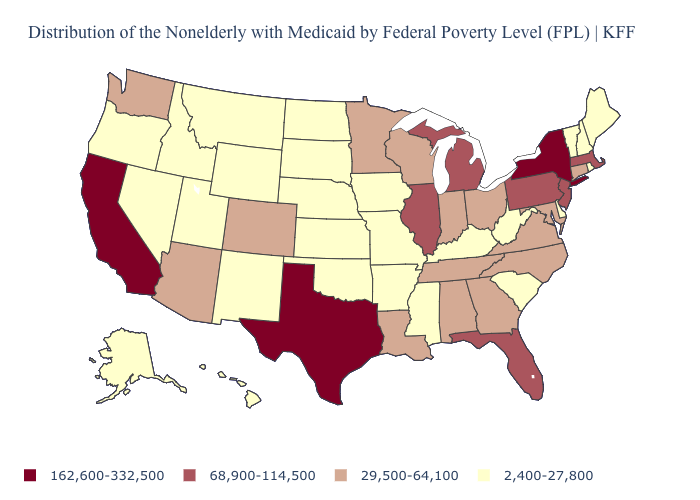Among the states that border Vermont , does New Hampshire have the highest value?
Concise answer only. No. What is the value of South Carolina?
Write a very short answer. 2,400-27,800. Which states hav the highest value in the West?
Concise answer only. California. What is the highest value in states that border Maryland?
Concise answer only. 68,900-114,500. Name the states that have a value in the range 162,600-332,500?
Give a very brief answer. California, New York, Texas. Among the states that border Indiana , which have the lowest value?
Quick response, please. Kentucky. Does Nevada have the same value as West Virginia?
Quick response, please. Yes. Name the states that have a value in the range 29,500-64,100?
Answer briefly. Alabama, Arizona, Colorado, Connecticut, Georgia, Indiana, Louisiana, Maryland, Minnesota, North Carolina, Ohio, Tennessee, Virginia, Washington, Wisconsin. What is the value of New Jersey?
Keep it brief. 68,900-114,500. Which states have the highest value in the USA?
Short answer required. California, New York, Texas. What is the value of West Virginia?
Write a very short answer. 2,400-27,800. What is the value of West Virginia?
Short answer required. 2,400-27,800. How many symbols are there in the legend?
Give a very brief answer. 4. What is the value of Massachusetts?
Quick response, please. 68,900-114,500. Name the states that have a value in the range 162,600-332,500?
Be succinct. California, New York, Texas. 